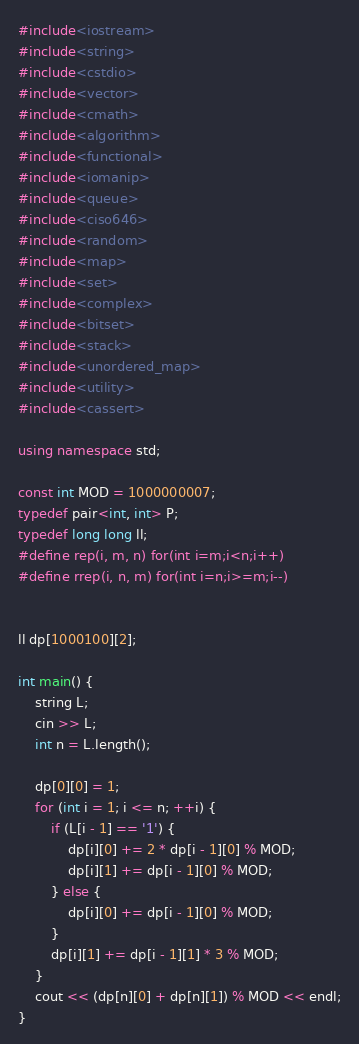Convert code to text. <code><loc_0><loc_0><loc_500><loc_500><_C++_>#include<iostream>
#include<string>
#include<cstdio>
#include<vector>
#include<cmath>
#include<algorithm>
#include<functional>
#include<iomanip>
#include<queue>
#include<ciso646>
#include<random>
#include<map>
#include<set>
#include<complex>
#include<bitset>
#include<stack>
#include<unordered_map>
#include<utility>
#include<cassert>

using namespace std;

const int MOD = 1000000007;
typedef pair<int, int> P;
typedef long long ll;
#define rep(i, m, n) for(int i=m;i<n;i++)
#define rrep(i, n, m) for(int i=n;i>=m;i--)


ll dp[1000100][2];

int main() {
    string L;
    cin >> L;
    int n = L.length();

    dp[0][0] = 1;
    for (int i = 1; i <= n; ++i) {
        if (L[i - 1] == '1') {
            dp[i][0] += 2 * dp[i - 1][0] % MOD;
            dp[i][1] += dp[i - 1][0] % MOD;
        } else {
            dp[i][0] += dp[i - 1][0] % MOD;
        }
        dp[i][1] += dp[i - 1][1] * 3 % MOD;
    }
    cout << (dp[n][0] + dp[n][1]) % MOD << endl;
}</code> 